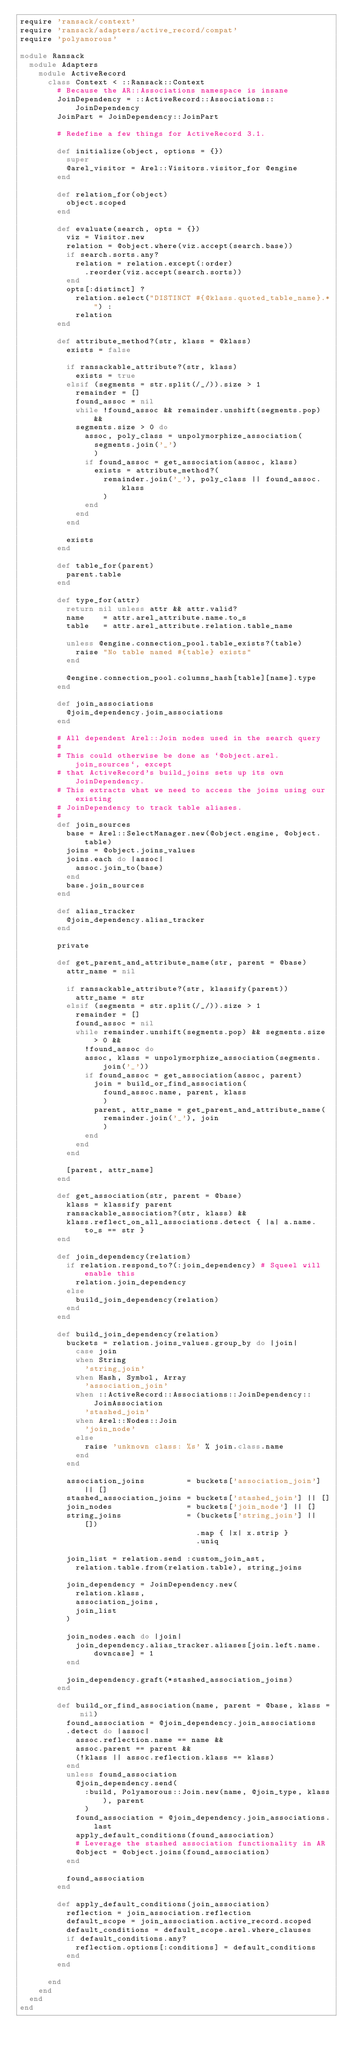<code> <loc_0><loc_0><loc_500><loc_500><_Ruby_>require 'ransack/context'
require 'ransack/adapters/active_record/compat'
require 'polyamorous'

module Ransack
  module Adapters
    module ActiveRecord
      class Context < ::Ransack::Context
        # Because the AR::Associations namespace is insane
        JoinDependency = ::ActiveRecord::Associations::JoinDependency
        JoinPart = JoinDependency::JoinPart

        # Redefine a few things for ActiveRecord 3.1.

        def initialize(object, options = {})
          super
          @arel_visitor = Arel::Visitors.visitor_for @engine
        end

        def relation_for(object)
          object.scoped
        end

        def evaluate(search, opts = {})
          viz = Visitor.new
          relation = @object.where(viz.accept(search.base))
          if search.sorts.any?
            relation = relation.except(:order)
              .reorder(viz.accept(search.sorts))
          end
          opts[:distinct] ?
            relation.select("DISTINCT #{@klass.quoted_table_name}.*") :
            relation
        end

        def attribute_method?(str, klass = @klass)
          exists = false

          if ransackable_attribute?(str, klass)
            exists = true
          elsif (segments = str.split(/_/)).size > 1
            remainder = []
            found_assoc = nil
            while !found_assoc && remainder.unshift(segments.pop) &&
            segments.size > 0 do
              assoc, poly_class = unpolymorphize_association(
                segments.join('_')
                )
              if found_assoc = get_association(assoc, klass)
                exists = attribute_method?(
                  remainder.join('_'), poly_class || found_assoc.klass
                  )
              end
            end
          end

          exists
        end

        def table_for(parent)
          parent.table
        end

        def type_for(attr)
          return nil unless attr && attr.valid?
          name    = attr.arel_attribute.name.to_s
          table   = attr.arel_attribute.relation.table_name

          unless @engine.connection_pool.table_exists?(table)
            raise "No table named #{table} exists"
          end

          @engine.connection_pool.columns_hash[table][name].type
        end

        def join_associations
          @join_dependency.join_associations
        end

        # All dependent Arel::Join nodes used in the search query
        #
        # This could otherwise be done as `@object.arel.join_sources`, except
        # that ActiveRecord's build_joins sets up its own JoinDependency.
        # This extracts what we need to access the joins using our existing
        # JoinDependency to track table aliases.
        #
        def join_sources
          base = Arel::SelectManager.new(@object.engine, @object.table)
          joins = @object.joins_values
          joins.each do |assoc|
            assoc.join_to(base)
          end
          base.join_sources
        end

        def alias_tracker
          @join_dependency.alias_tracker
        end

        private

        def get_parent_and_attribute_name(str, parent = @base)
          attr_name = nil

          if ransackable_attribute?(str, klassify(parent))
            attr_name = str
          elsif (segments = str.split(/_/)).size > 1
            remainder = []
            found_assoc = nil
            while remainder.unshift(segments.pop) && segments.size > 0 &&
              !found_assoc do
              assoc, klass = unpolymorphize_association(segments.join('_'))
              if found_assoc = get_association(assoc, parent)
                join = build_or_find_association(
                  found_assoc.name, parent, klass
                  )
                parent, attr_name = get_parent_and_attribute_name(
                  remainder.join('_'), join
                  )
              end
            end
          end

          [parent, attr_name]
        end

        def get_association(str, parent = @base)
          klass = klassify parent
          ransackable_association?(str, klass) &&
          klass.reflect_on_all_associations.detect { |a| a.name.to_s == str }
        end

        def join_dependency(relation)
          if relation.respond_to?(:join_dependency) # Squeel will enable this
            relation.join_dependency
          else
            build_join_dependency(relation)
          end
        end

        def build_join_dependency(relation)
          buckets = relation.joins_values.group_by do |join|
            case join
            when String
              'string_join'
            when Hash, Symbol, Array
              'association_join'
            when ::ActiveRecord::Associations::JoinDependency::JoinAssociation
              'stashed_join'
            when Arel::Nodes::Join
              'join_node'
            else
              raise 'unknown class: %s' % join.class.name
            end
          end

          association_joins         = buckets['association_join'] || []
          stashed_association_joins = buckets['stashed_join'] || []
          join_nodes                = buckets['join_node'] || []
          string_joins              = (buckets['string_join'] || [])
                                      .map { |x| x.strip }
                                      .uniq

          join_list = relation.send :custom_join_ast,
            relation.table.from(relation.table), string_joins

          join_dependency = JoinDependency.new(
            relation.klass,
            association_joins,
            join_list
          )

          join_nodes.each do |join|
            join_dependency.alias_tracker.aliases[join.left.name.downcase] = 1
          end

          join_dependency.graft(*stashed_association_joins)
        end

        def build_or_find_association(name, parent = @base, klass = nil)
          found_association = @join_dependency.join_associations
          .detect do |assoc|
            assoc.reflection.name == name &&
            assoc.parent == parent &&
            (!klass || assoc.reflection.klass == klass)
          end
          unless found_association
            @join_dependency.send(
              :build, Polyamorous::Join.new(name, @join_type, klass), parent
              )
            found_association = @join_dependency.join_associations.last
            apply_default_conditions(found_association)
            # Leverage the stashed association functionality in AR
            @object = @object.joins(found_association)
          end

          found_association
        end

        def apply_default_conditions(join_association)
          reflection = join_association.reflection
          default_scope = join_association.active_record.scoped
          default_conditions = default_scope.arel.where_clauses
          if default_conditions.any?
            reflection.options[:conditions] = default_conditions
          end
        end

      end
    end
  end
end
</code> 